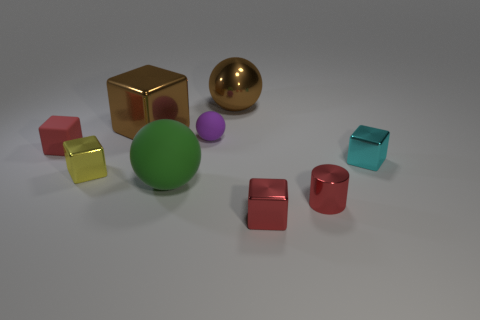How would you describe the overall composition of the objects in the image? The composition is an assortment of geometrically shaped objects with various colors, sizes, and materials. There's a sense of static balance, with the objects seemingly placed without order, yet each holds its space distinctly in the scene, creating a visually satisfying diversity. 